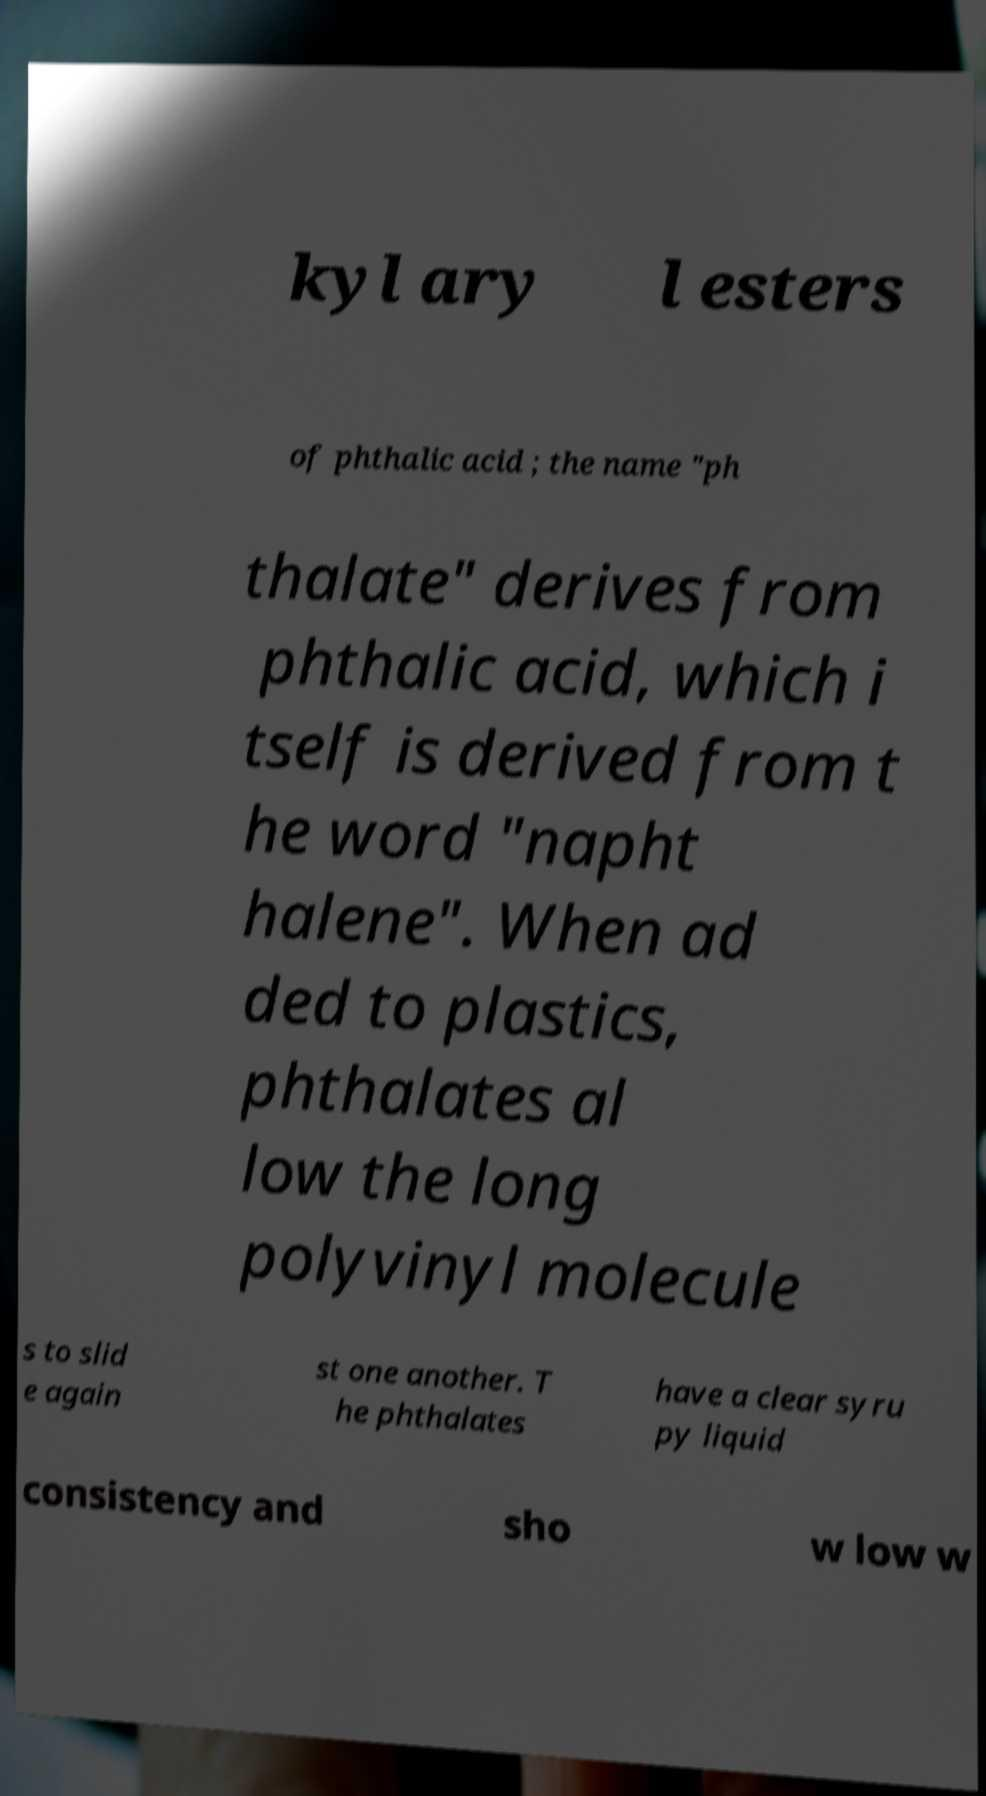There's text embedded in this image that I need extracted. Can you transcribe it verbatim? kyl ary l esters of phthalic acid ; the name "ph thalate" derives from phthalic acid, which i tself is derived from t he word "napht halene". When ad ded to plastics, phthalates al low the long polyvinyl molecule s to slid e again st one another. T he phthalates have a clear syru py liquid consistency and sho w low w 